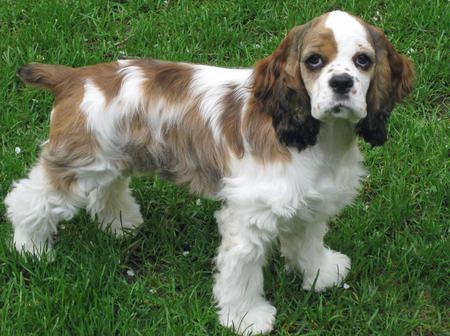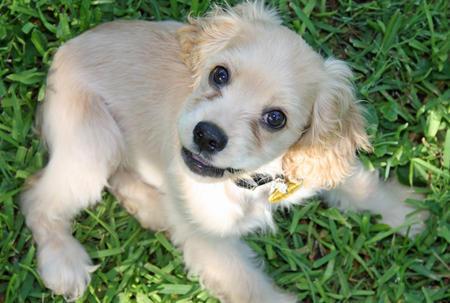The first image is the image on the left, the second image is the image on the right. For the images displayed, is the sentence "Right image shows one dog on green grass, and the dog has white fur on its face with darker fur on its earsand around its eyes." factually correct? Answer yes or no. No. The first image is the image on the left, the second image is the image on the right. Evaluate the accuracy of this statement regarding the images: "The dogs in both images are sitting on the grass.". Is it true? Answer yes or no. No. 